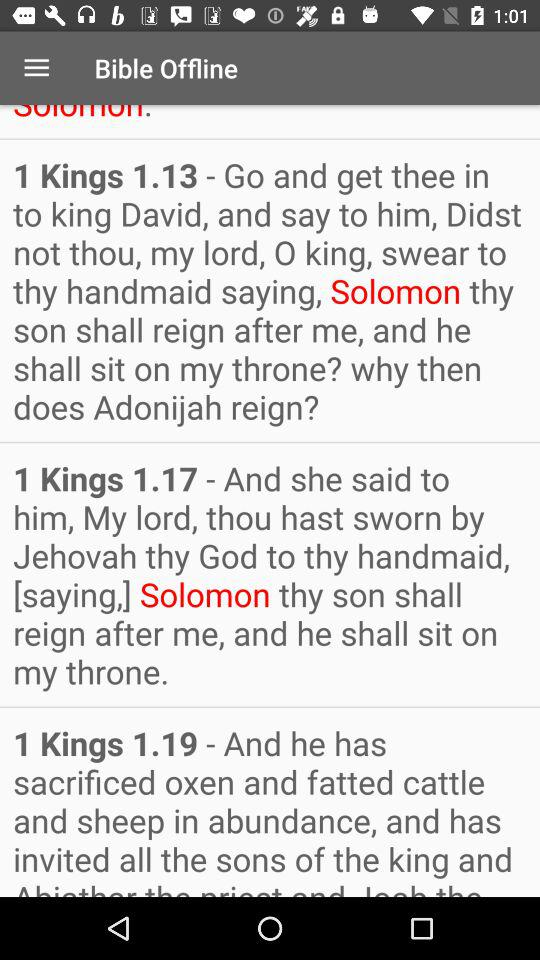What's the application name? The application name is "Bible Offline". 